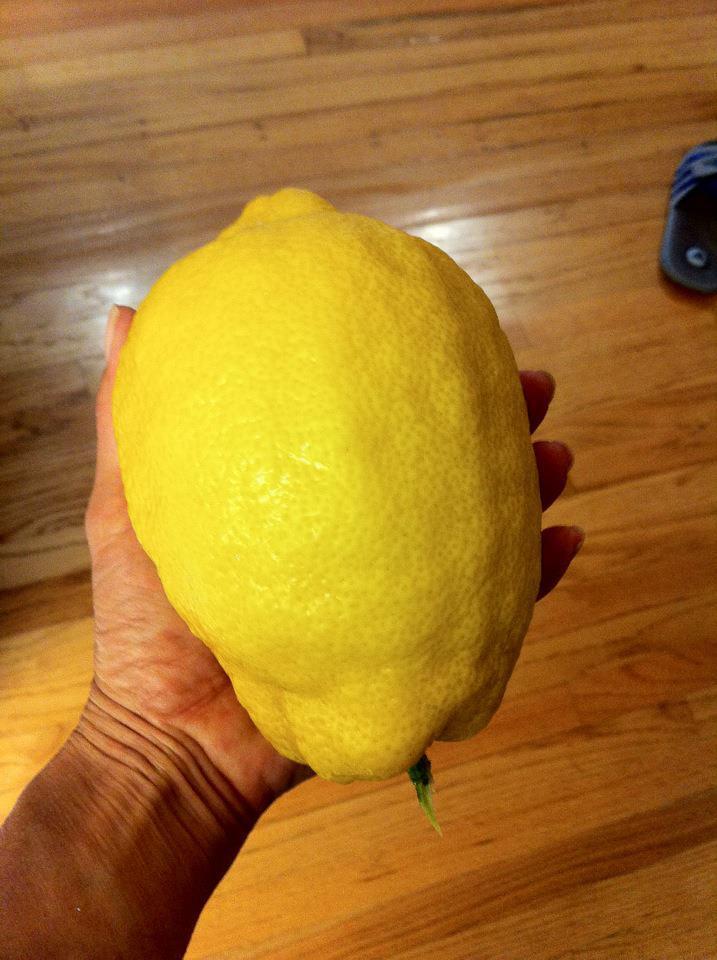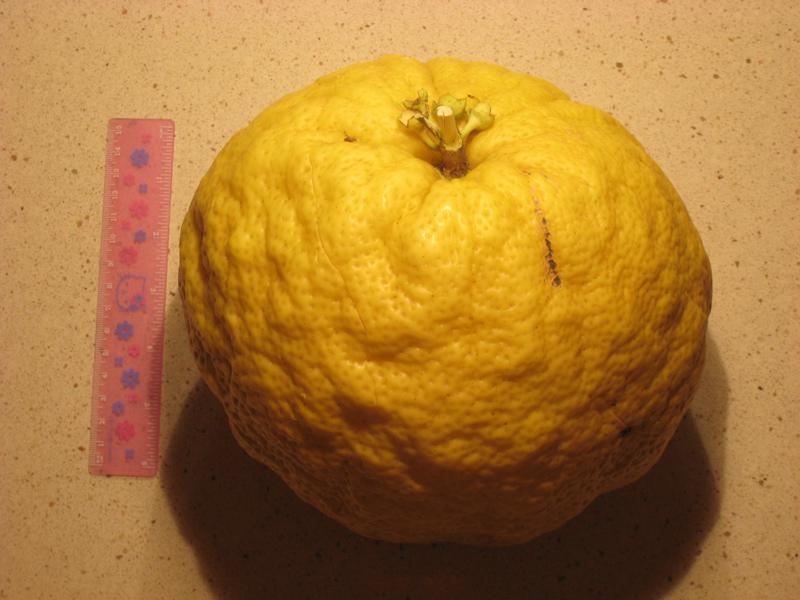The first image is the image on the left, the second image is the image on the right. Analyze the images presented: Is the assertion "The right image includes yellow fruit in a round bowl, and the left image shows a small fruit on the left of a larger fruit of the same color." valid? Answer yes or no. No. The first image is the image on the left, the second image is the image on the right. Examine the images to the left and right. Is the description "The left image shows two fruit next to each other, one large and one small, while the right image shows at least three fruit in a bowl." accurate? Answer yes or no. No. 